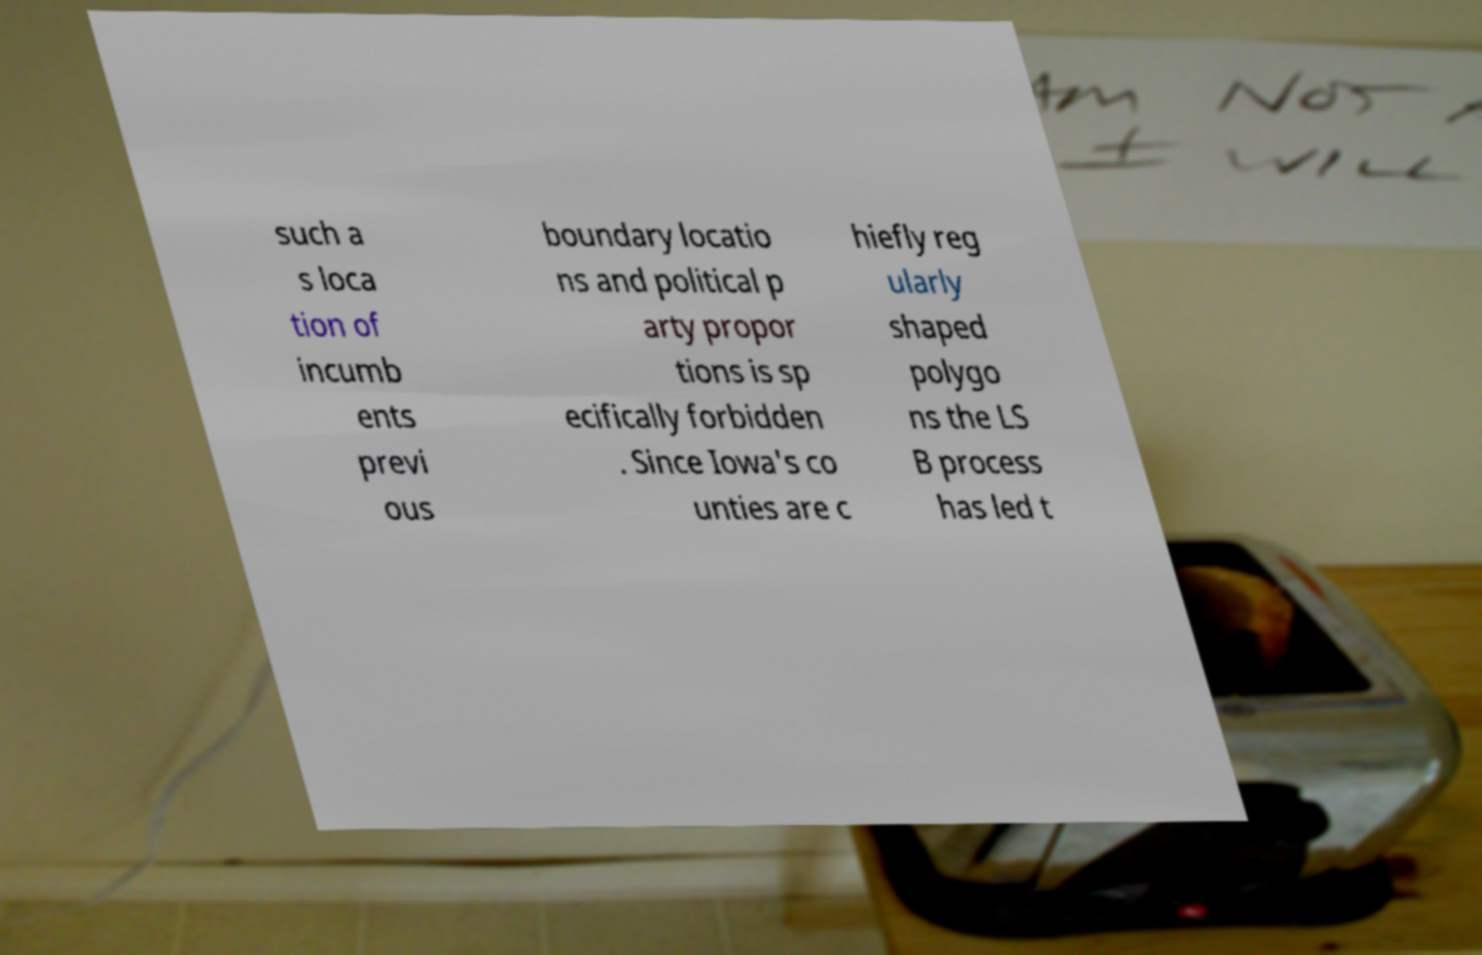Could you assist in decoding the text presented in this image and type it out clearly? such a s loca tion of incumb ents previ ous boundary locatio ns and political p arty propor tions is sp ecifically forbidden . Since Iowa's co unties are c hiefly reg ularly shaped polygo ns the LS B process has led t 